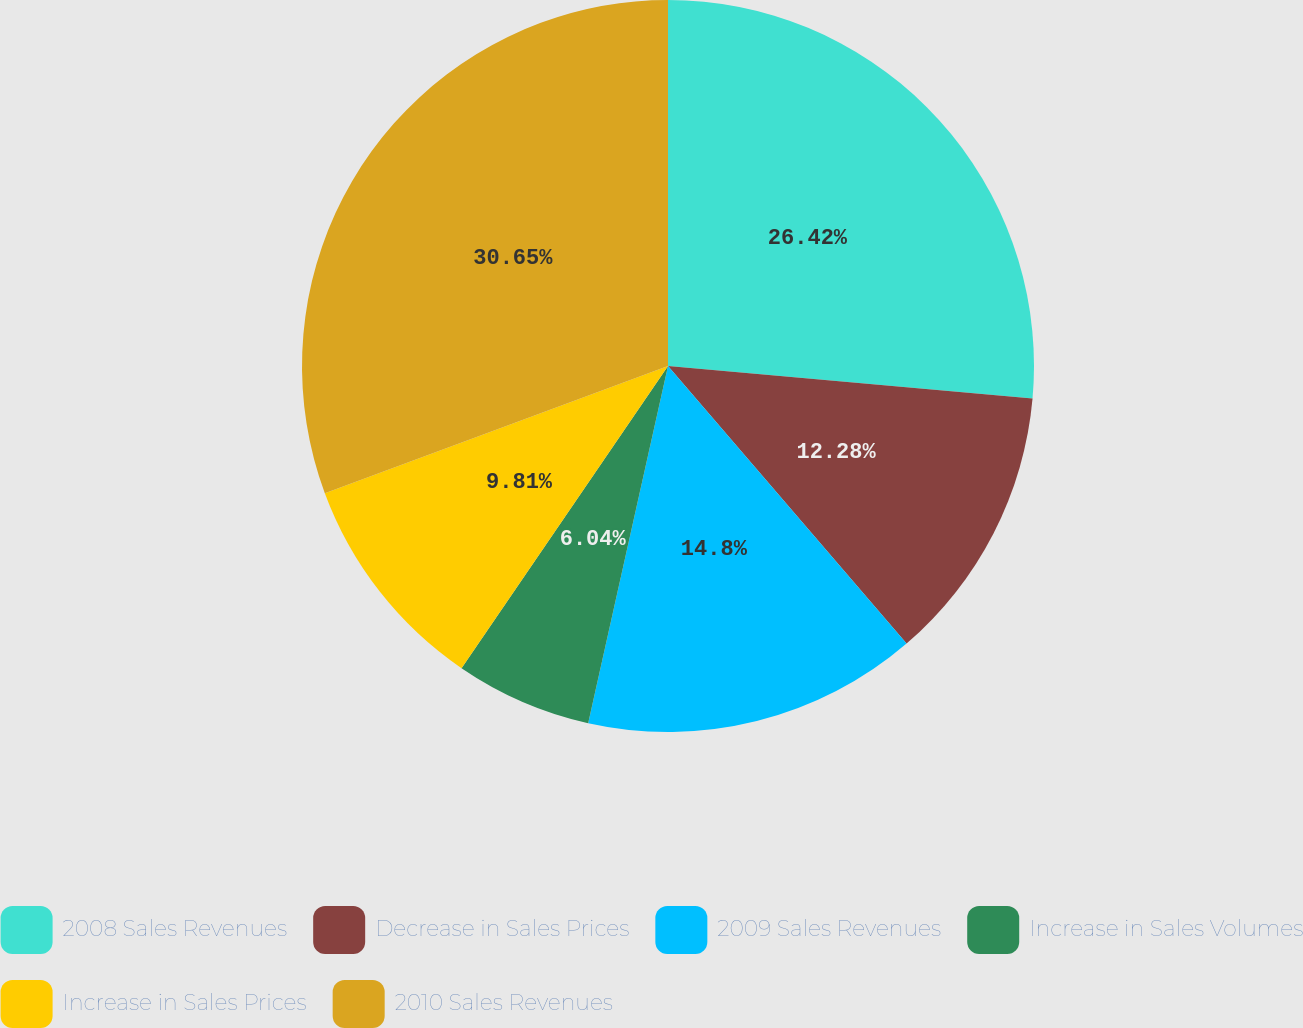<chart> <loc_0><loc_0><loc_500><loc_500><pie_chart><fcel>2008 Sales Revenues<fcel>Decrease in Sales Prices<fcel>2009 Sales Revenues<fcel>Increase in Sales Volumes<fcel>Increase in Sales Prices<fcel>2010 Sales Revenues<nl><fcel>26.42%<fcel>12.28%<fcel>14.8%<fcel>6.04%<fcel>9.81%<fcel>30.65%<nl></chart> 